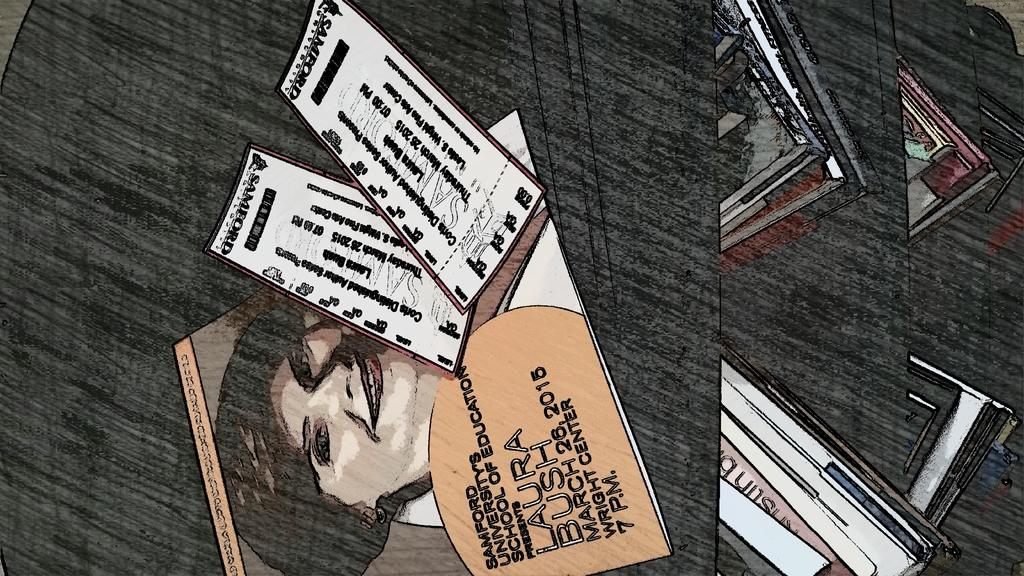What is the main subject of the image? There is a painting in the image. What does the painting depict? The painting depicts a woman. Are there any other paintings visible in the image? Yes, there are other paintings in the image. What is the color of the background in the image? The background of the image is black. Can you tell me how many kites are hanging from the jar in the image? There is no jar or kites present in the image; it features a painting and other paintings with a black background. What type of books are visible on the bookshelf in the image? There is no bookshelf or books present in the image; it features a painting and other paintings with a black background. 